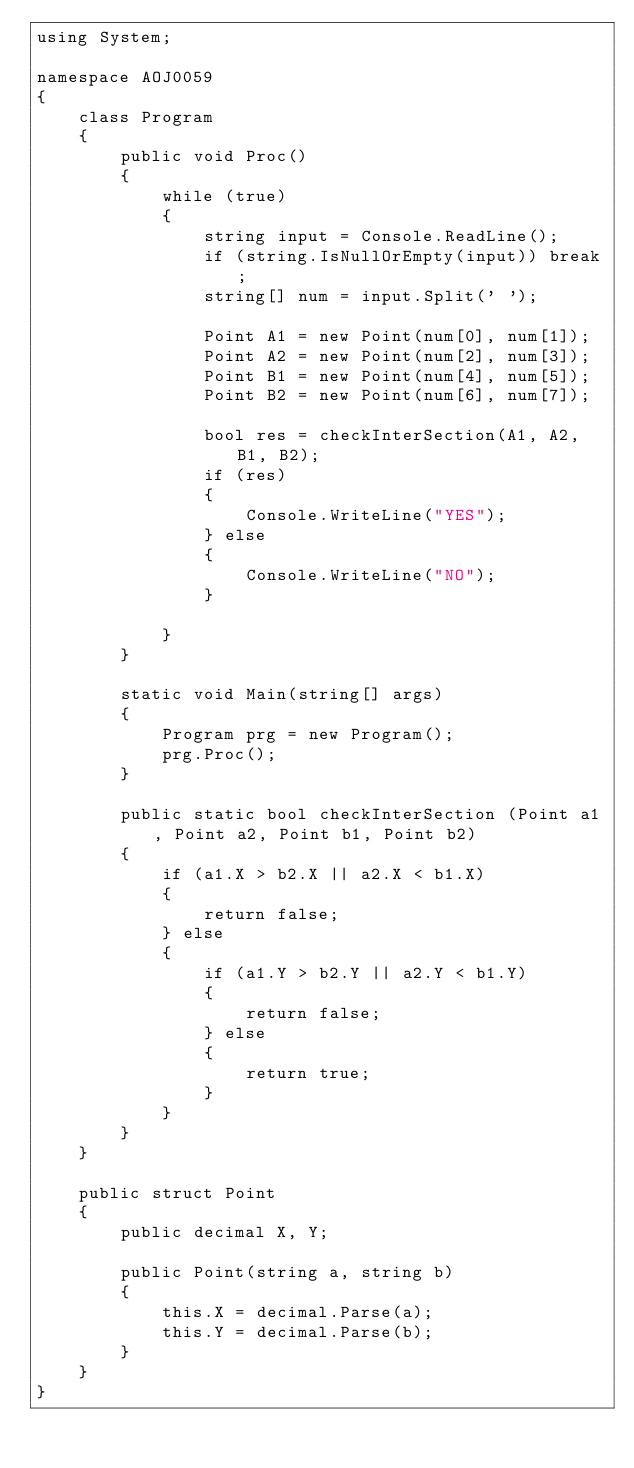<code> <loc_0><loc_0><loc_500><loc_500><_C#_>using System;

namespace AOJ0059
{
    class Program
    {
        public void Proc()
        {
            while (true)
            {
                string input = Console.ReadLine();
                if (string.IsNullOrEmpty(input)) break;
                string[] num = input.Split(' ');

                Point A1 = new Point(num[0], num[1]);
                Point A2 = new Point(num[2], num[3]);
                Point B1 = new Point(num[4], num[5]);
                Point B2 = new Point(num[6], num[7]);

                bool res = checkInterSection(A1, A2, B1, B2);
                if (res)
                {
                    Console.WriteLine("YES");
                } else
                {
                    Console.WriteLine("NO");
                }

            }
        }

        static void Main(string[] args)
        {
            Program prg = new Program();
            prg.Proc();
        }

        public static bool checkInterSection (Point a1, Point a2, Point b1, Point b2)
        {
            if (a1.X > b2.X || a2.X < b1.X)
            {
                return false;
            } else
            {
                if (a1.Y > b2.Y || a2.Y < b1.Y)
                {
                    return false;
                } else
                {
                    return true;
                }
            }
        }
    }

    public struct Point
    {
        public decimal X, Y;

        public Point(string a, string b)
        {
            this.X = decimal.Parse(a);
            this.Y = decimal.Parse(b);
        }
    }
}</code> 